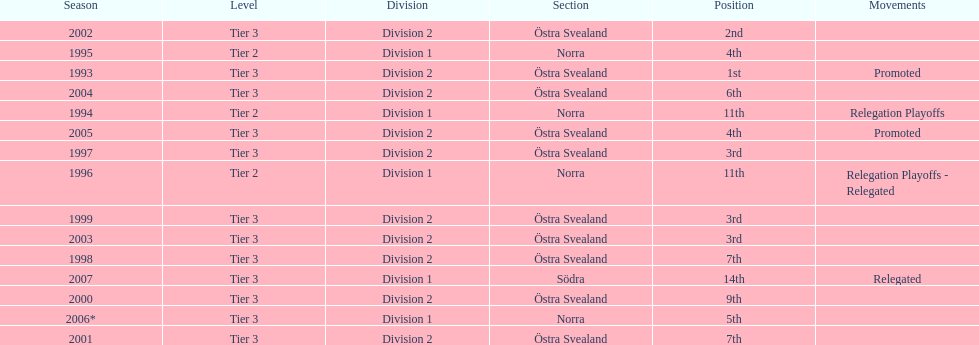What is listed under the movements column of the last season? Relegated. Would you mind parsing the complete table? {'header': ['Season', 'Level', 'Division', 'Section', 'Position', 'Movements'], 'rows': [['2002', 'Tier 3', 'Division 2', 'Östra Svealand', '2nd', ''], ['1995', 'Tier 2', 'Division 1', 'Norra', '4th', ''], ['1993', 'Tier 3', 'Division 2', 'Östra Svealand', '1st', 'Promoted'], ['2004', 'Tier 3', 'Division 2', 'Östra Svealand', '6th', ''], ['1994', 'Tier 2', 'Division 1', 'Norra', '11th', 'Relegation Playoffs'], ['2005', 'Tier 3', 'Division 2', 'Östra Svealand', '4th', 'Promoted'], ['1997', 'Tier 3', 'Division 2', 'Östra Svealand', '3rd', ''], ['1996', 'Tier 2', 'Division 1', 'Norra', '11th', 'Relegation Playoffs - Relegated'], ['1999', 'Tier 3', 'Division 2', 'Östra Svealand', '3rd', ''], ['2003', 'Tier 3', 'Division 2', 'Östra Svealand', '3rd', ''], ['1998', 'Tier 3', 'Division 2', 'Östra Svealand', '7th', ''], ['2007', 'Tier 3', 'Division 1', 'Södra', '14th', 'Relegated'], ['2000', 'Tier 3', 'Division 2', 'Östra Svealand', '9th', ''], ['2006*', 'Tier 3', 'Division 1', 'Norra', '5th', ''], ['2001', 'Tier 3', 'Division 2', 'Östra Svealand', '7th', '']]} 